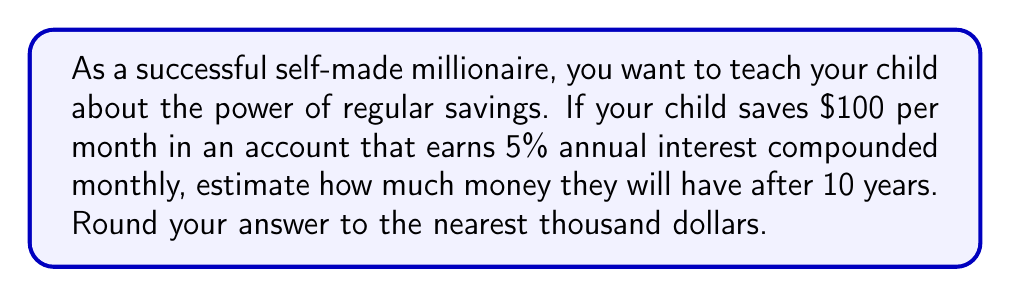Provide a solution to this math problem. Let's break this down step-by-step:

1) First, we need to understand the formula for compound interest with regular contributions:

   $$ A = P \cdot (1 + \frac{r}{n})^{nt} + C \cdot \frac{(1 + \frac{r}{n})^{nt} - 1}{\frac{r}{n}} $$

   Where:
   $A$ = final amount
   $P$ = principal (initial investment)
   $r$ = annual interest rate (as a decimal)
   $n$ = number of times interest is compounded per year
   $t$ = number of years
   $C$ = regular contribution amount

2) In this case:
   $P = 0$ (no initial investment)
   $r = 0.05$ (5% annual interest)
   $n = 12$ (compounded monthly)
   $t = 10$ years
   $C = 100$ (monthly contribution)

3) Let's substitute these values into the formula:

   $$ A = 0 \cdot (1 + \frac{0.05}{12})^{12 \cdot 10} + 100 \cdot \frac{(1 + \frac{0.05}{12})^{12 \cdot 10} - 1}{\frac{0.05}{12}} $$

4) Simplify:

   $$ A = 100 \cdot \frac{(1 + 0.004167)^{120} - 1}{0.004167} $$

5) Use a calculator to evaluate this expression:

   $$ A \approx 15,528.23 $$

6) Rounding to the nearest thousand:

   $$ A \approx 16,000 $$

This demonstrates the power of compound interest and regular savings over time.
Answer: $16,000 